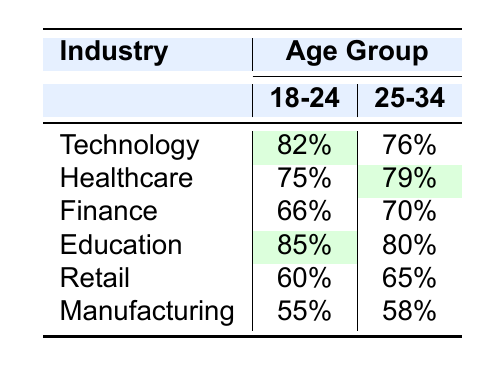What is the job satisfaction percentage for the Technology industry among those aged 25-34? From the table, we can look under the Technology row and the age group column for 25-34. The corresponding value is 76%.
Answer: 76% Which industry has the highest job satisfaction percentage for the age group 18-24? By comparing the job satisfaction percentages in the 18-24 column, Education has the highest value at 85%.
Answer: Education Is the job satisfaction for the Healthcare industry higher among the 25-34 age group than among the 18-24 age group? For Healthcare, the job satisfaction percentages are 79% for 25-34 and 75% for 18-24. Since 79% is greater than 75%, the statement is true.
Answer: Yes What is the difference in job satisfaction percentages for the Retail industry between the two age groups? The percentage for the 18-24 age group in Retail is 60%, and for the 25-34 age group, it is 65%. The difference is calculated as 65% - 60% = 5%.
Answer: 5% Average the job satisfaction percentages for the Manufacturing industry across the two age groups. The percentages for Manufacturing are 55% for 18-24 and 58% for 25-34. To find the average, we sum them (55% + 58%) which equals 113%, and then divide by 2, giving us 113% / 2 = 56.5%.
Answer: 56.5% Is there any industry listed that has a job satisfaction percentage of less than 60% for the age group 18-24? Checking the 18-24 column, the Manufacturing industry has a job satisfaction of 55%, which is less than 60%. Therefore, the answer is yes.
Answer: Yes Which age group in the Finance industry has the lower job satisfaction percentage? In the Finance row, the percentages show 66% for the 18-24 age group and 70% for the 25-34 age group. Thus, the age group 18-24 has the lower satisfaction.
Answer: 18-24 What is the overall trend in job satisfaction for industries like Technology and Healthcare from 18-24 to 25-34 age groups? Observing the percentages; Technology goes from 82% to 76% (a decrease), and Healthcare goes from 75% to 79% (an increase). Therefore, there is a mixed trend: Technology shows a decrease while Healthcare shows an increase.
Answer: Mixed trend 